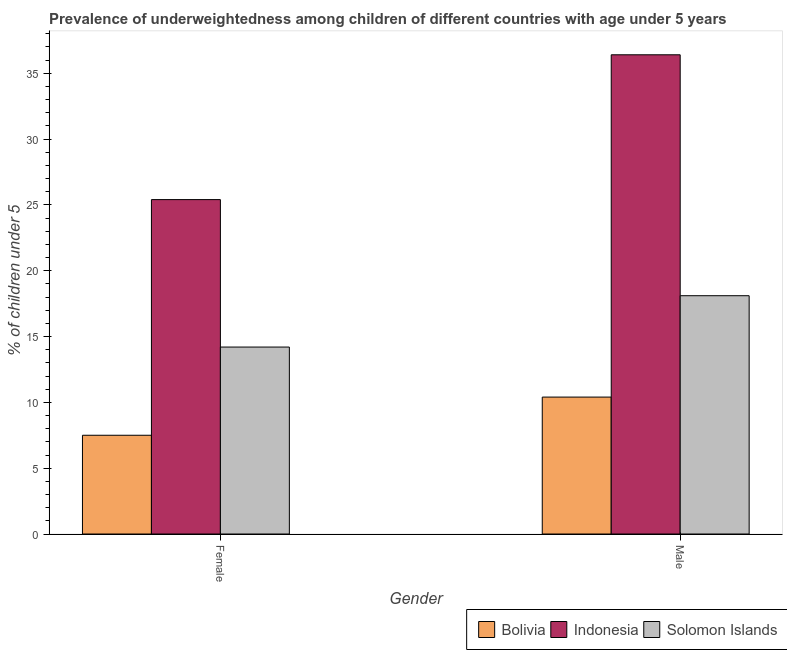How many bars are there on the 2nd tick from the left?
Provide a succinct answer. 3. How many bars are there on the 2nd tick from the right?
Keep it short and to the point. 3. What is the label of the 1st group of bars from the left?
Keep it short and to the point. Female. What is the percentage of underweighted male children in Bolivia?
Provide a succinct answer. 10.4. Across all countries, what is the maximum percentage of underweighted male children?
Provide a short and direct response. 36.4. In which country was the percentage of underweighted female children minimum?
Keep it short and to the point. Bolivia. What is the total percentage of underweighted male children in the graph?
Keep it short and to the point. 64.9. What is the difference between the percentage of underweighted male children in Indonesia and that in Solomon Islands?
Provide a succinct answer. 18.3. What is the difference between the percentage of underweighted female children in Indonesia and the percentage of underweighted male children in Bolivia?
Your answer should be compact. 15. What is the average percentage of underweighted male children per country?
Keep it short and to the point. 21.63. What is the difference between the percentage of underweighted female children and percentage of underweighted male children in Solomon Islands?
Offer a terse response. -3.9. What is the ratio of the percentage of underweighted female children in Solomon Islands to that in Bolivia?
Offer a very short reply. 1.89. What does the 3rd bar from the left in Male represents?
Ensure brevity in your answer.  Solomon Islands. What does the 1st bar from the right in Female represents?
Provide a short and direct response. Solomon Islands. How many bars are there?
Your answer should be very brief. 6. Are all the bars in the graph horizontal?
Make the answer very short. No. Are the values on the major ticks of Y-axis written in scientific E-notation?
Provide a succinct answer. No. Does the graph contain grids?
Your response must be concise. No. Where does the legend appear in the graph?
Give a very brief answer. Bottom right. How are the legend labels stacked?
Make the answer very short. Horizontal. What is the title of the graph?
Provide a short and direct response. Prevalence of underweightedness among children of different countries with age under 5 years. Does "High income: OECD" appear as one of the legend labels in the graph?
Make the answer very short. No. What is the label or title of the X-axis?
Offer a terse response. Gender. What is the label or title of the Y-axis?
Your answer should be compact.  % of children under 5. What is the  % of children under 5 of Indonesia in Female?
Provide a short and direct response. 25.4. What is the  % of children under 5 in Solomon Islands in Female?
Keep it short and to the point. 14.2. What is the  % of children under 5 of Bolivia in Male?
Offer a very short reply. 10.4. What is the  % of children under 5 of Indonesia in Male?
Your response must be concise. 36.4. What is the  % of children under 5 in Solomon Islands in Male?
Provide a short and direct response. 18.1. Across all Gender, what is the maximum  % of children under 5 of Bolivia?
Offer a terse response. 10.4. Across all Gender, what is the maximum  % of children under 5 of Indonesia?
Provide a short and direct response. 36.4. Across all Gender, what is the maximum  % of children under 5 in Solomon Islands?
Offer a terse response. 18.1. Across all Gender, what is the minimum  % of children under 5 in Indonesia?
Ensure brevity in your answer.  25.4. Across all Gender, what is the minimum  % of children under 5 of Solomon Islands?
Your response must be concise. 14.2. What is the total  % of children under 5 in Indonesia in the graph?
Give a very brief answer. 61.8. What is the total  % of children under 5 in Solomon Islands in the graph?
Provide a short and direct response. 32.3. What is the difference between the  % of children under 5 of Indonesia in Female and that in Male?
Your answer should be very brief. -11. What is the difference between the  % of children under 5 in Solomon Islands in Female and that in Male?
Provide a short and direct response. -3.9. What is the difference between the  % of children under 5 in Bolivia in Female and the  % of children under 5 in Indonesia in Male?
Your response must be concise. -28.9. What is the difference between the  % of children under 5 in Bolivia in Female and the  % of children under 5 in Solomon Islands in Male?
Ensure brevity in your answer.  -10.6. What is the average  % of children under 5 of Bolivia per Gender?
Your answer should be very brief. 8.95. What is the average  % of children under 5 of Indonesia per Gender?
Offer a terse response. 30.9. What is the average  % of children under 5 in Solomon Islands per Gender?
Provide a short and direct response. 16.15. What is the difference between the  % of children under 5 in Bolivia and  % of children under 5 in Indonesia in Female?
Your response must be concise. -17.9. What is the difference between the  % of children under 5 of Bolivia and  % of children under 5 of Solomon Islands in Female?
Give a very brief answer. -6.7. What is the difference between the  % of children under 5 of Bolivia and  % of children under 5 of Solomon Islands in Male?
Your response must be concise. -7.7. What is the difference between the  % of children under 5 in Indonesia and  % of children under 5 in Solomon Islands in Male?
Your answer should be compact. 18.3. What is the ratio of the  % of children under 5 in Bolivia in Female to that in Male?
Keep it short and to the point. 0.72. What is the ratio of the  % of children under 5 of Indonesia in Female to that in Male?
Give a very brief answer. 0.7. What is the ratio of the  % of children under 5 of Solomon Islands in Female to that in Male?
Give a very brief answer. 0.78. What is the difference between the highest and the lowest  % of children under 5 of Bolivia?
Make the answer very short. 2.9. What is the difference between the highest and the lowest  % of children under 5 of Indonesia?
Give a very brief answer. 11. 